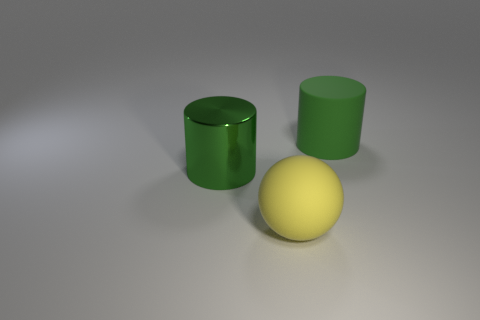Are there the same number of big matte cylinders that are behind the rubber cylinder and big green shiny things?
Provide a short and direct response. No. How big is the rubber ball?
Your answer should be very brief. Large. There is another cylinder that is the same color as the big rubber cylinder; what material is it?
Offer a very short reply. Metal. How many large cylinders have the same color as the large sphere?
Provide a short and direct response. 0. Do the green shiny cylinder and the yellow ball have the same size?
Make the answer very short. Yes. What size is the cylinder on the right side of the big green object that is in front of the green matte object?
Offer a terse response. Large. Is the color of the big metal cylinder the same as the big rubber thing on the right side of the large yellow ball?
Provide a short and direct response. Yes. Are there any cyan balls that have the same size as the green rubber cylinder?
Provide a short and direct response. No. There is a rubber thing behind the large yellow matte object; what is its size?
Provide a short and direct response. Large. There is a cylinder that is behind the big green shiny thing; is there a big green matte cylinder that is in front of it?
Keep it short and to the point. No. 